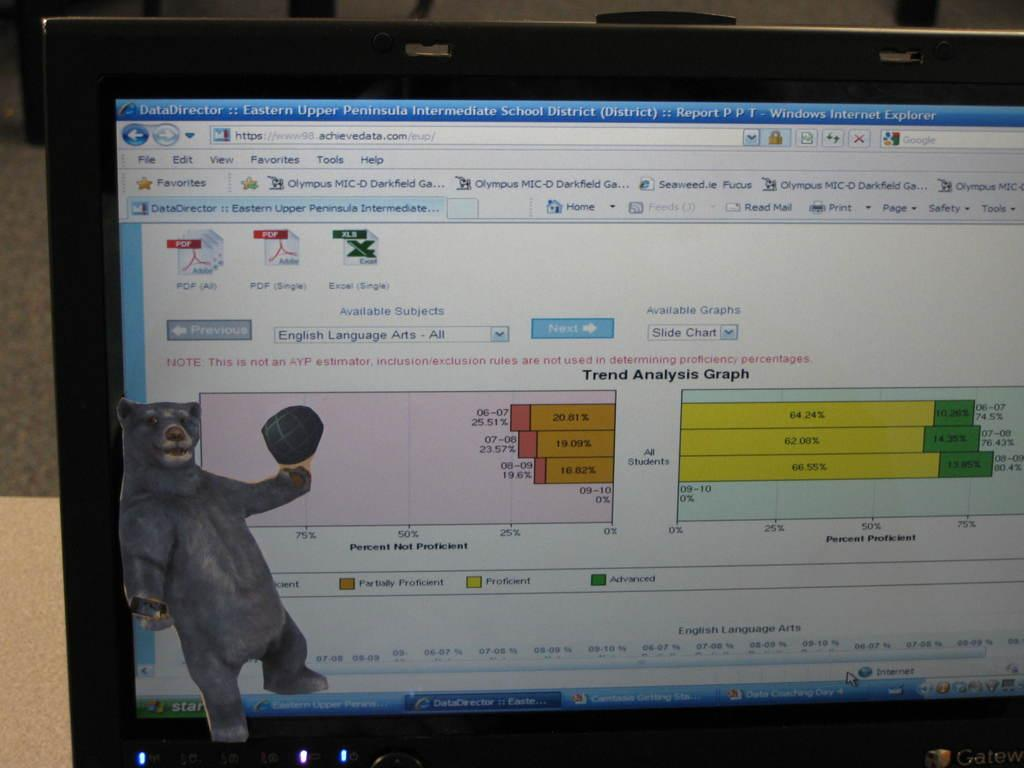<image>
Provide a brief description of the given image. A pc monitor opened to a tab with Eastern Upper Peninsula  Intermediate School District. 